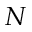<formula> <loc_0><loc_0><loc_500><loc_500>N</formula> 